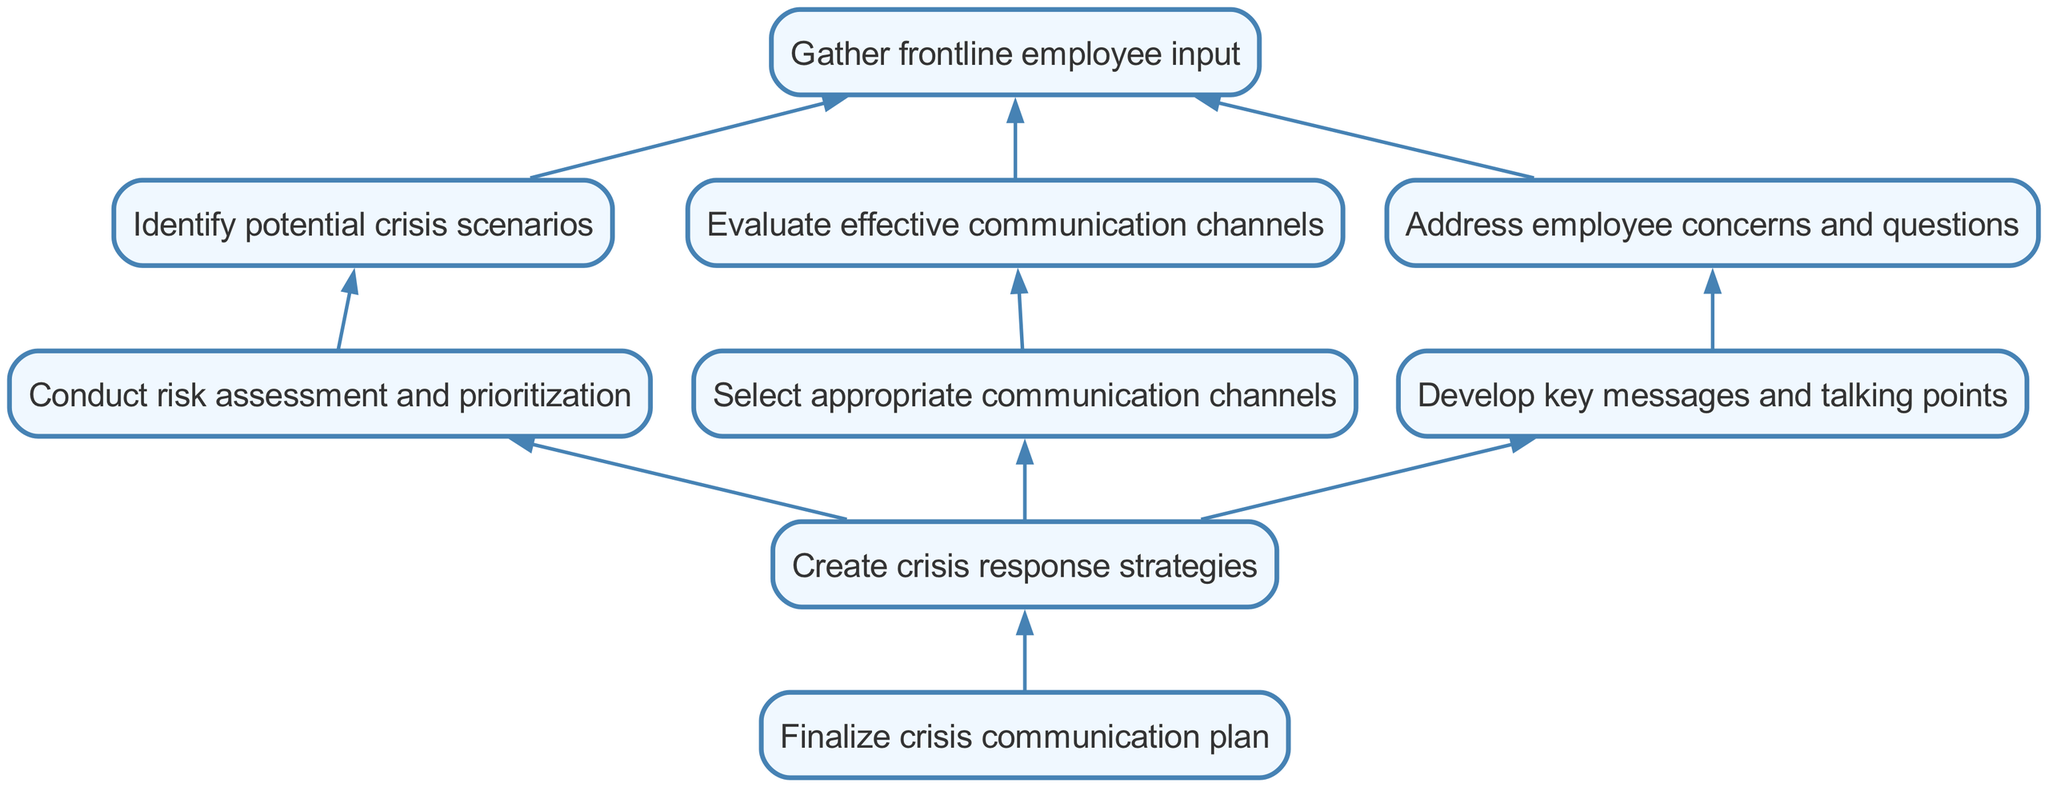What is the first step in creating a crisis communication plan? The diagram indicates that the first step is to "Gather frontline employee input," which starts the process of developing a crisis communication plan.
Answer: Gather frontline employee input How many nodes are there in the diagram? By counting the unique elements in the diagram, there are a total of nine nodes representing different steps in the process.
Answer: Nine What is the final outcome according to the diagram? The last node represents the outcome of the process, which is "Finalize crisis communication plan."
Answer: Finalize crisis communication plan What follows after addressing employee concerns and questions? The flow indicates that after addressing employee concerns and questions, the next step is "Develop key messages and talking points."
Answer: Develop key messages and talking points What connects "Communicate channels" and "Create crisis response strategies"? Both nodes lead to the same subsequent step, which is "Create crisis response strategies," indicating that they are both part of the preparation for handling crises.
Answer: Create crisis response strategies Name the nodes that lead directly to "Create crisis response strategies." The nodes leading directly to "Create crisis response strategies" are "Conduct risk assessment and prioritization," "Select appropriate communication channels," and "Develop key messages and talking points."
Answer: Conduct risk assessment and prioritization, Select appropriate communication channels, Develop key messages and talking points Which node is considered the last in the hierarchy? The hierarchy shows that "Finalize crisis communication plan" is the terminal node with no further child nodes.
Answer: Finalize crisis communication plan How many child nodes does "Gather frontline employee input" have? "Gather frontline employee input" has three child nodes: "Identify potential crisis scenarios," "Evaluate effective communication channels," and "Address employee concerns and questions."
Answer: Three What is the relationship between "Identify potential crisis scenarios" and "Conduct risk assessment and prioritization"? "Identify potential crisis scenarios" directly leads to "Conduct risk assessment and prioritization," indicating that assessing risks depends on previously identified scenarios.
Answer: Directly leads to 